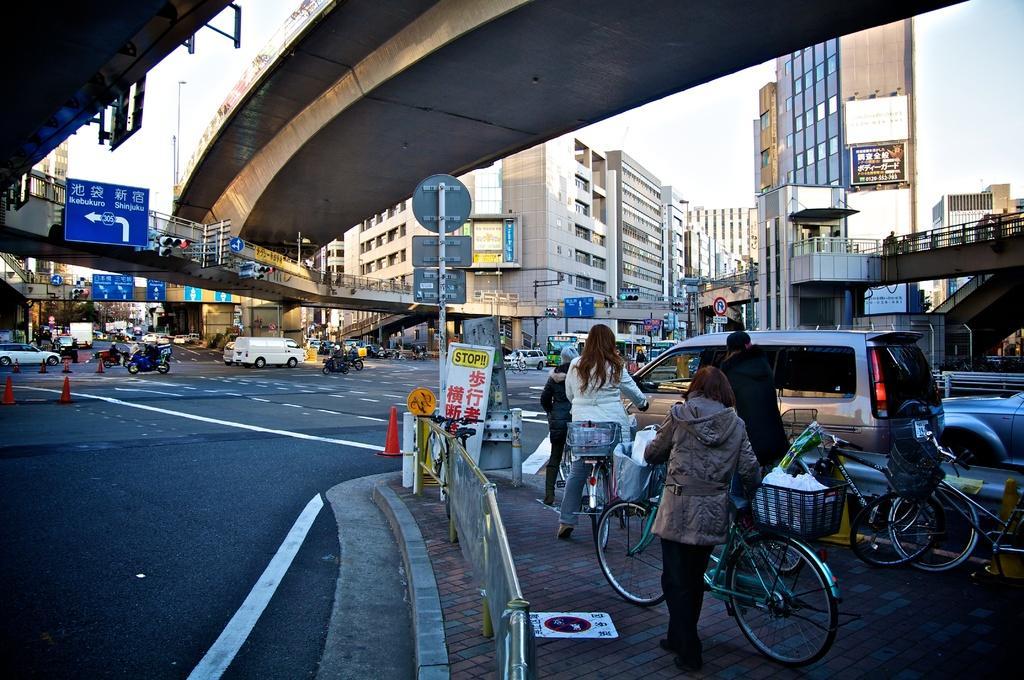Describe this image in one or two sentences. This picture is consists of a road view, where there are cars, bikes, and bridges above the road and there are buildings around the area of the image. 